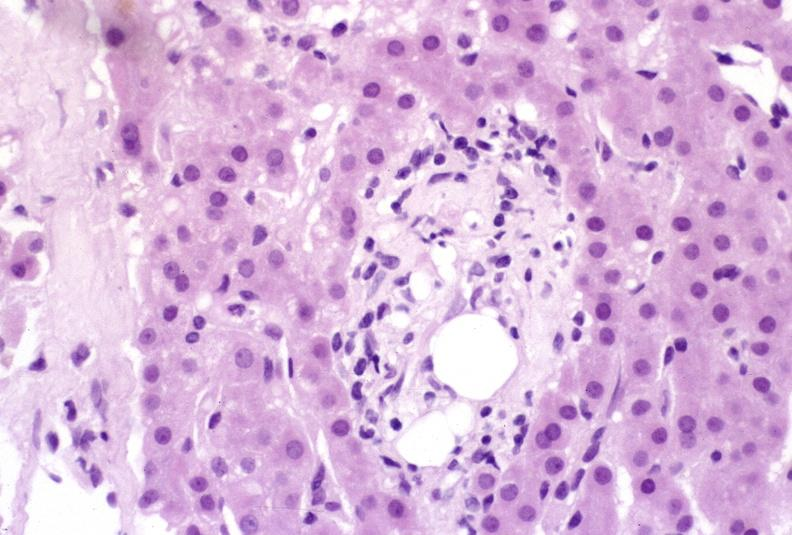what does this image show?
Answer the question using a single word or phrase. Ductopenia 